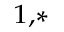<formula> <loc_0><loc_0><loc_500><loc_500>^ { 1 , \ast }</formula> 